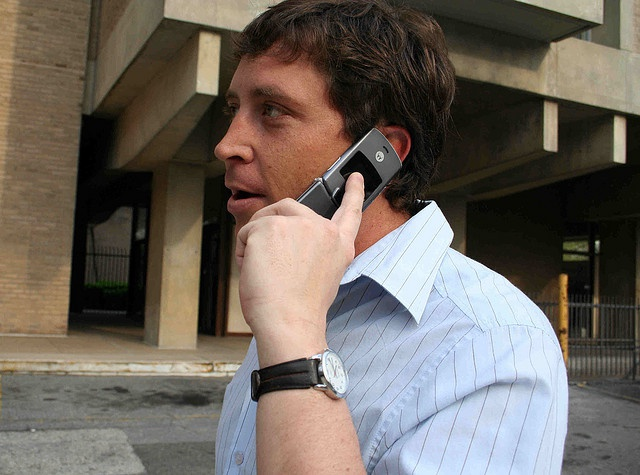Describe the objects in this image and their specific colors. I can see people in gray, lavender, black, brown, and tan tones and cell phone in gray, black, darkgray, and lightgray tones in this image. 